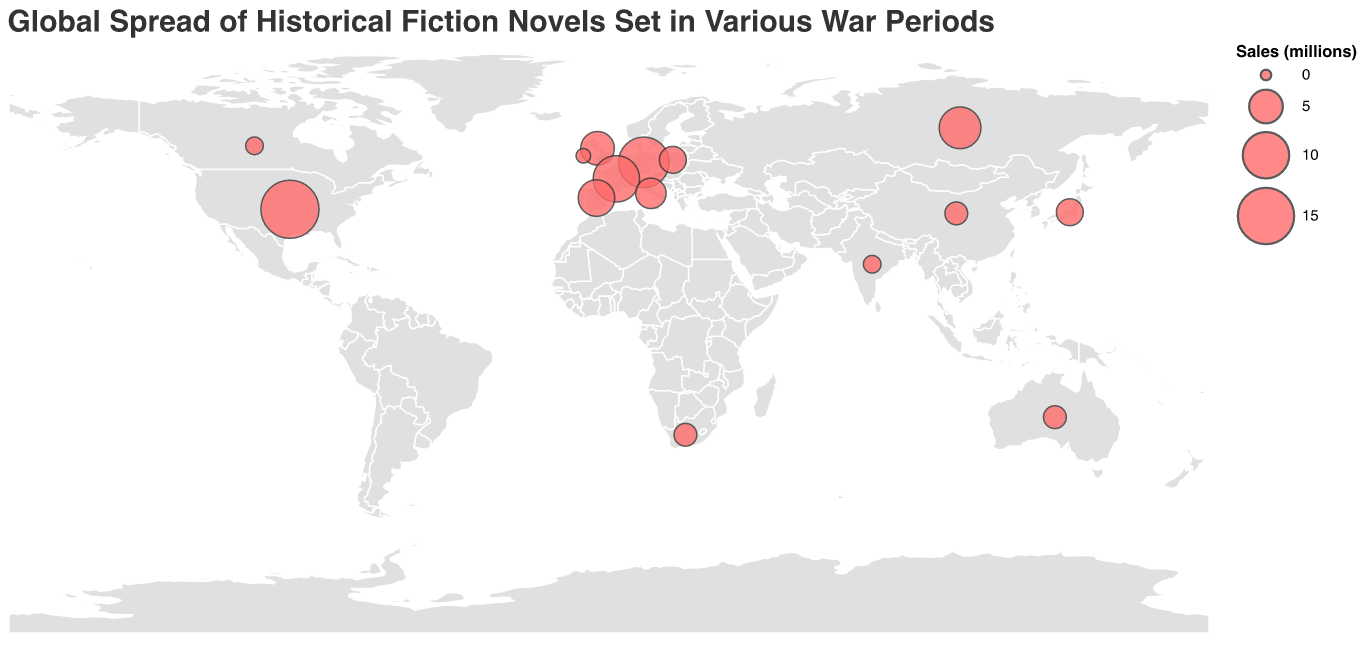What is the title of the figure? The title is usually written at the top of the figure. It provides a summary of what the figure is about.
Answer: Global Spread of Historical Fiction Novels Set in Various War Periods Which country is associated with the novel "War and Peace"? By looking at the tooltip or the label associated with the novel "War and Peace," we can identify that this novel is linked to a specific country.
Answer: Russia How many novels set during World War II are represented on the map? To determine this, count all the instances where the War Period is labeled as "World War II."
Answer: Four Which novel has the highest sales figures, and what are those figures? By examining the size of the circles or the tooltip information, we can identify the novel with the largest sales figures.
Answer: The Book Thief, 16 million Compare the sales figures of the novels from United Kingdom and United States. Which country has higher sales? The United Kingdom is associated with "Birdsong" with 5 million sales and the United States with "The Book Thief" with 16 million sales. Comparing these two values shows which is higher.
Answer: United States What is the average sales of the novels in this dataset? Adding all the sales figures and dividing by the number of data points will give the average sales. Summing all the sales (16 + 5 + 8 + 2 + 12 + 3 + 10 + 1 + 4 + 2 + 6 + 3 + 1 + 0.5 + 2) gives 75.5, and there are 15 novels, so the average is 75.5 / 15.
Answer: 5.03 million Which region between Europe and Asia has more novels listed in this dataset? By identifying the countries in Europe and Asia and counting the novels associated with each region, we can determine which region has more novels. Europe has the UK, Germany, France, Italy, Poland, Spain, Ireland, and Russia (8 novels), and Asia has Japan, China, and India (3 novels).
Answer: Europe What novel is associated with the Napoleonic Wars and in which country is it set? The tooltip or data point labeled with the Napoleonic Wars provides the answer.
Answer: War and Peace, Russia Is there a historical fiction novel set during the French Revolution listed in the dataset? If so, what is it? By scanning through the War Period labels for the French Revolution, we can identify the corresponding novel.
Answer: A Tale of Two Cities 